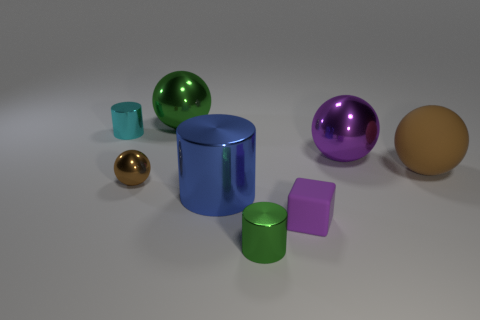Are the small cylinder that is on the right side of the big green metallic ball and the large cylinder made of the same material?
Your answer should be compact. Yes. There is a big purple object that is the same shape as the brown rubber thing; what is its material?
Your answer should be very brief. Metal. What is the material of the big thing that is the same color as the cube?
Provide a succinct answer. Metal. Are there fewer tiny purple matte things than big green cylinders?
Keep it short and to the point. No. There is a large sphere on the right side of the big purple thing; does it have the same color as the small rubber cube?
Keep it short and to the point. No. There is a tiny sphere that is the same material as the large cylinder; what color is it?
Your answer should be compact. Brown. Do the green shiny cylinder and the matte ball have the same size?
Provide a short and direct response. No. What is the material of the tiny green cylinder?
Your answer should be very brief. Metal. What material is the green thing that is the same size as the matte block?
Provide a short and direct response. Metal. Are there any cyan rubber cylinders that have the same size as the purple metal thing?
Offer a very short reply. No. 